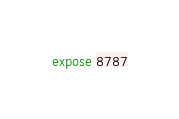Convert code to text. <code><loc_0><loc_0><loc_500><loc_500><_Dockerfile_>expose 8787</code> 